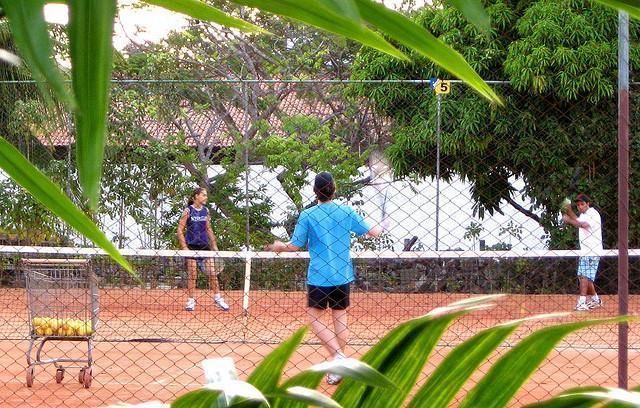How many people are in the picture?
Give a very brief answer. 3. 